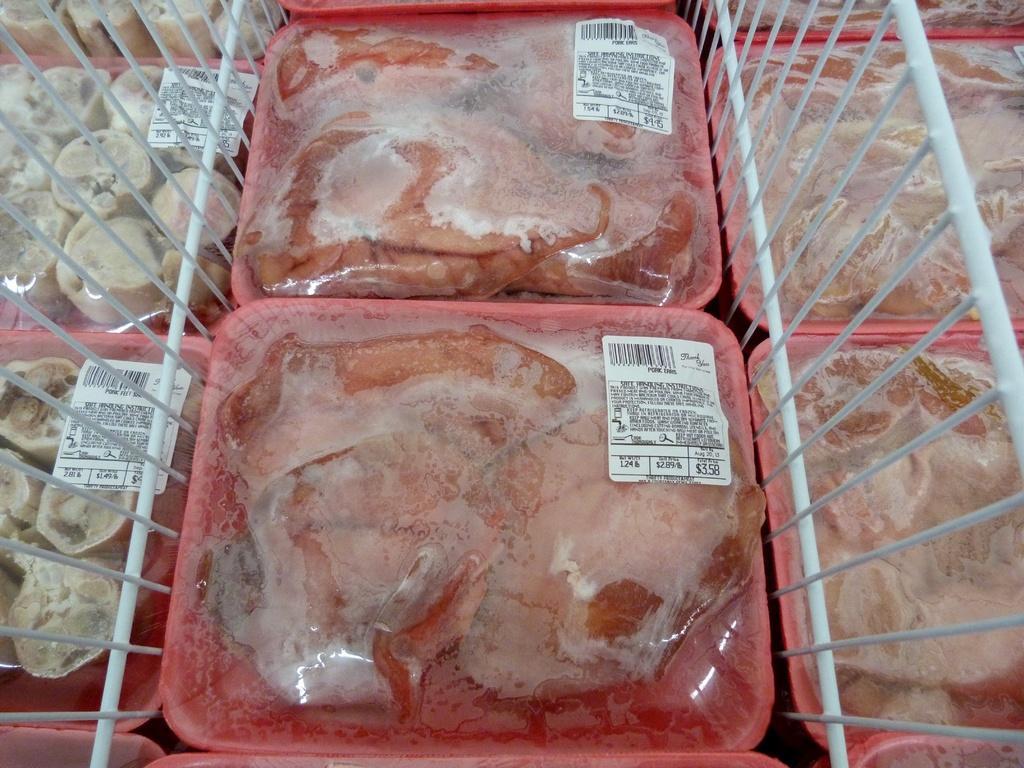Can you describe this image briefly? In this image we can see some plates containing meat placed on the surface. We can also see the metal grills. 